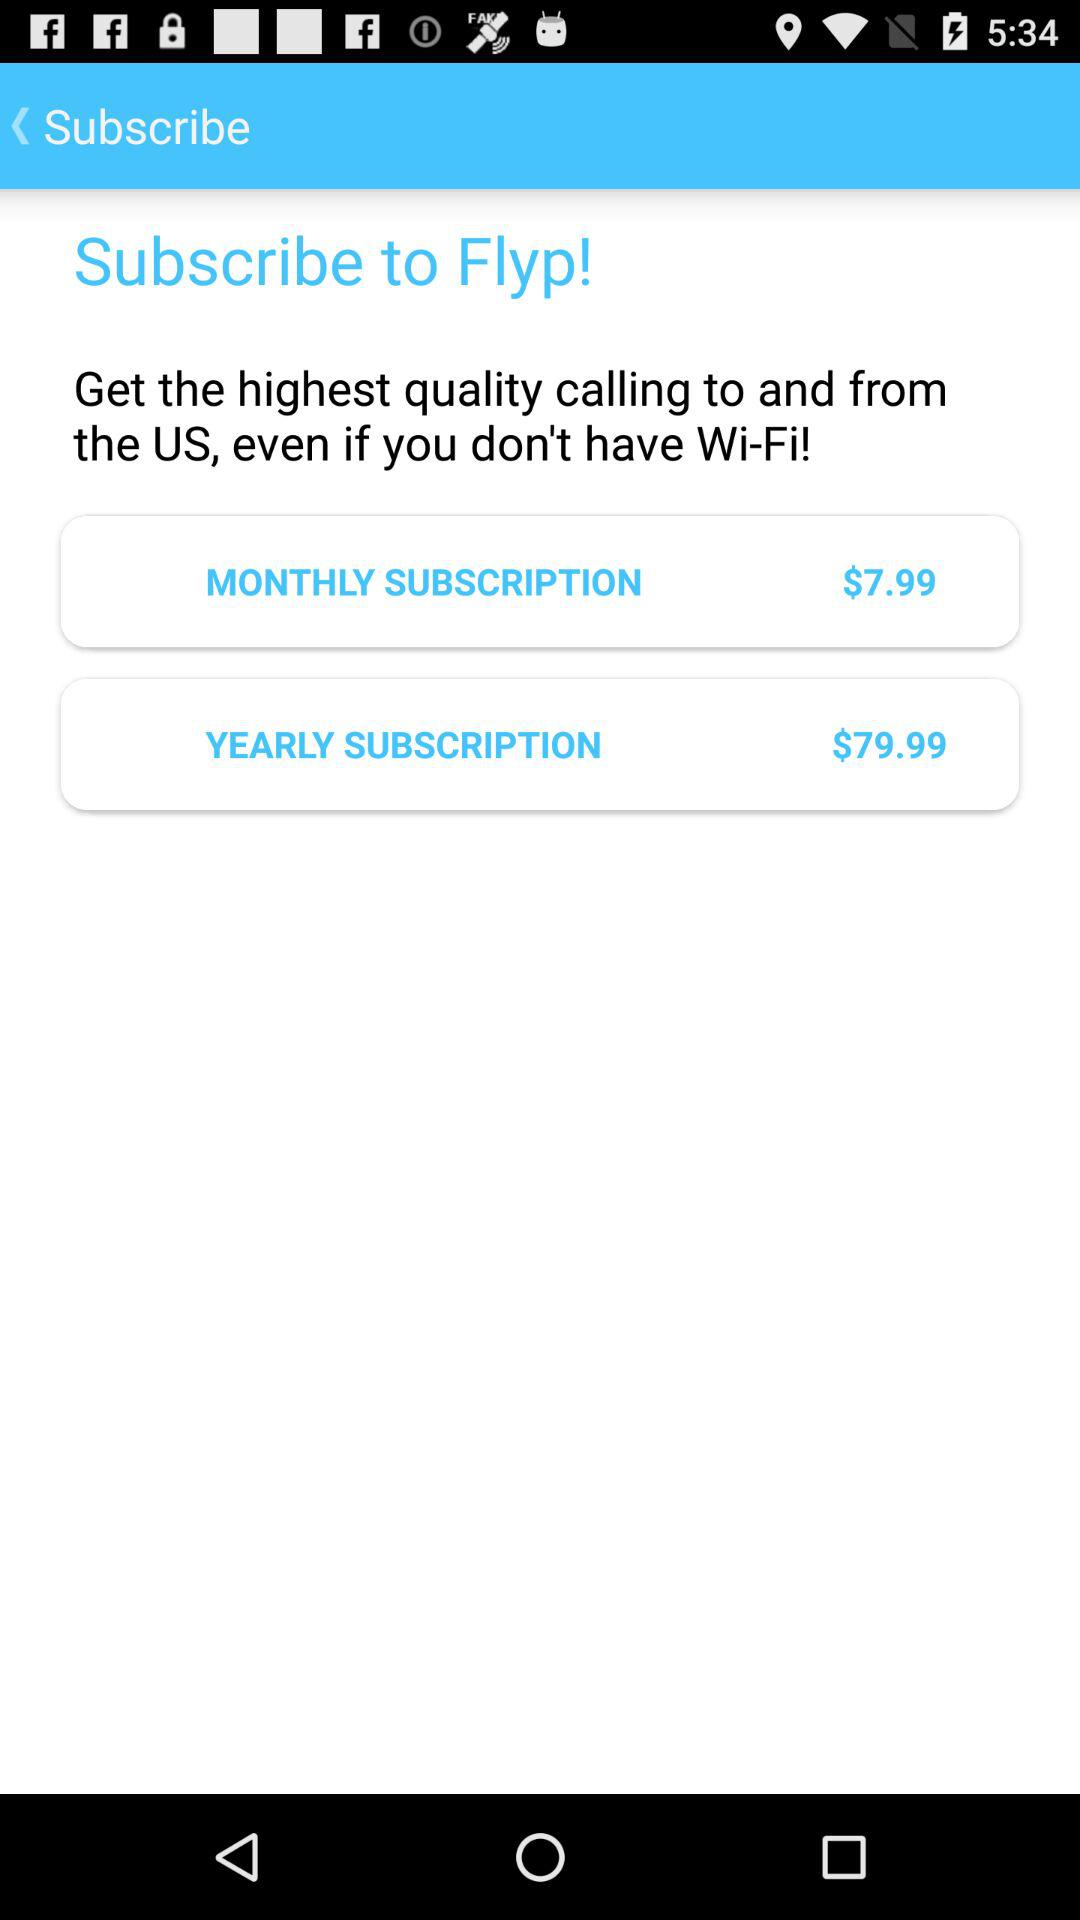What is the price of the monthly subscription? The price is $7.99. 